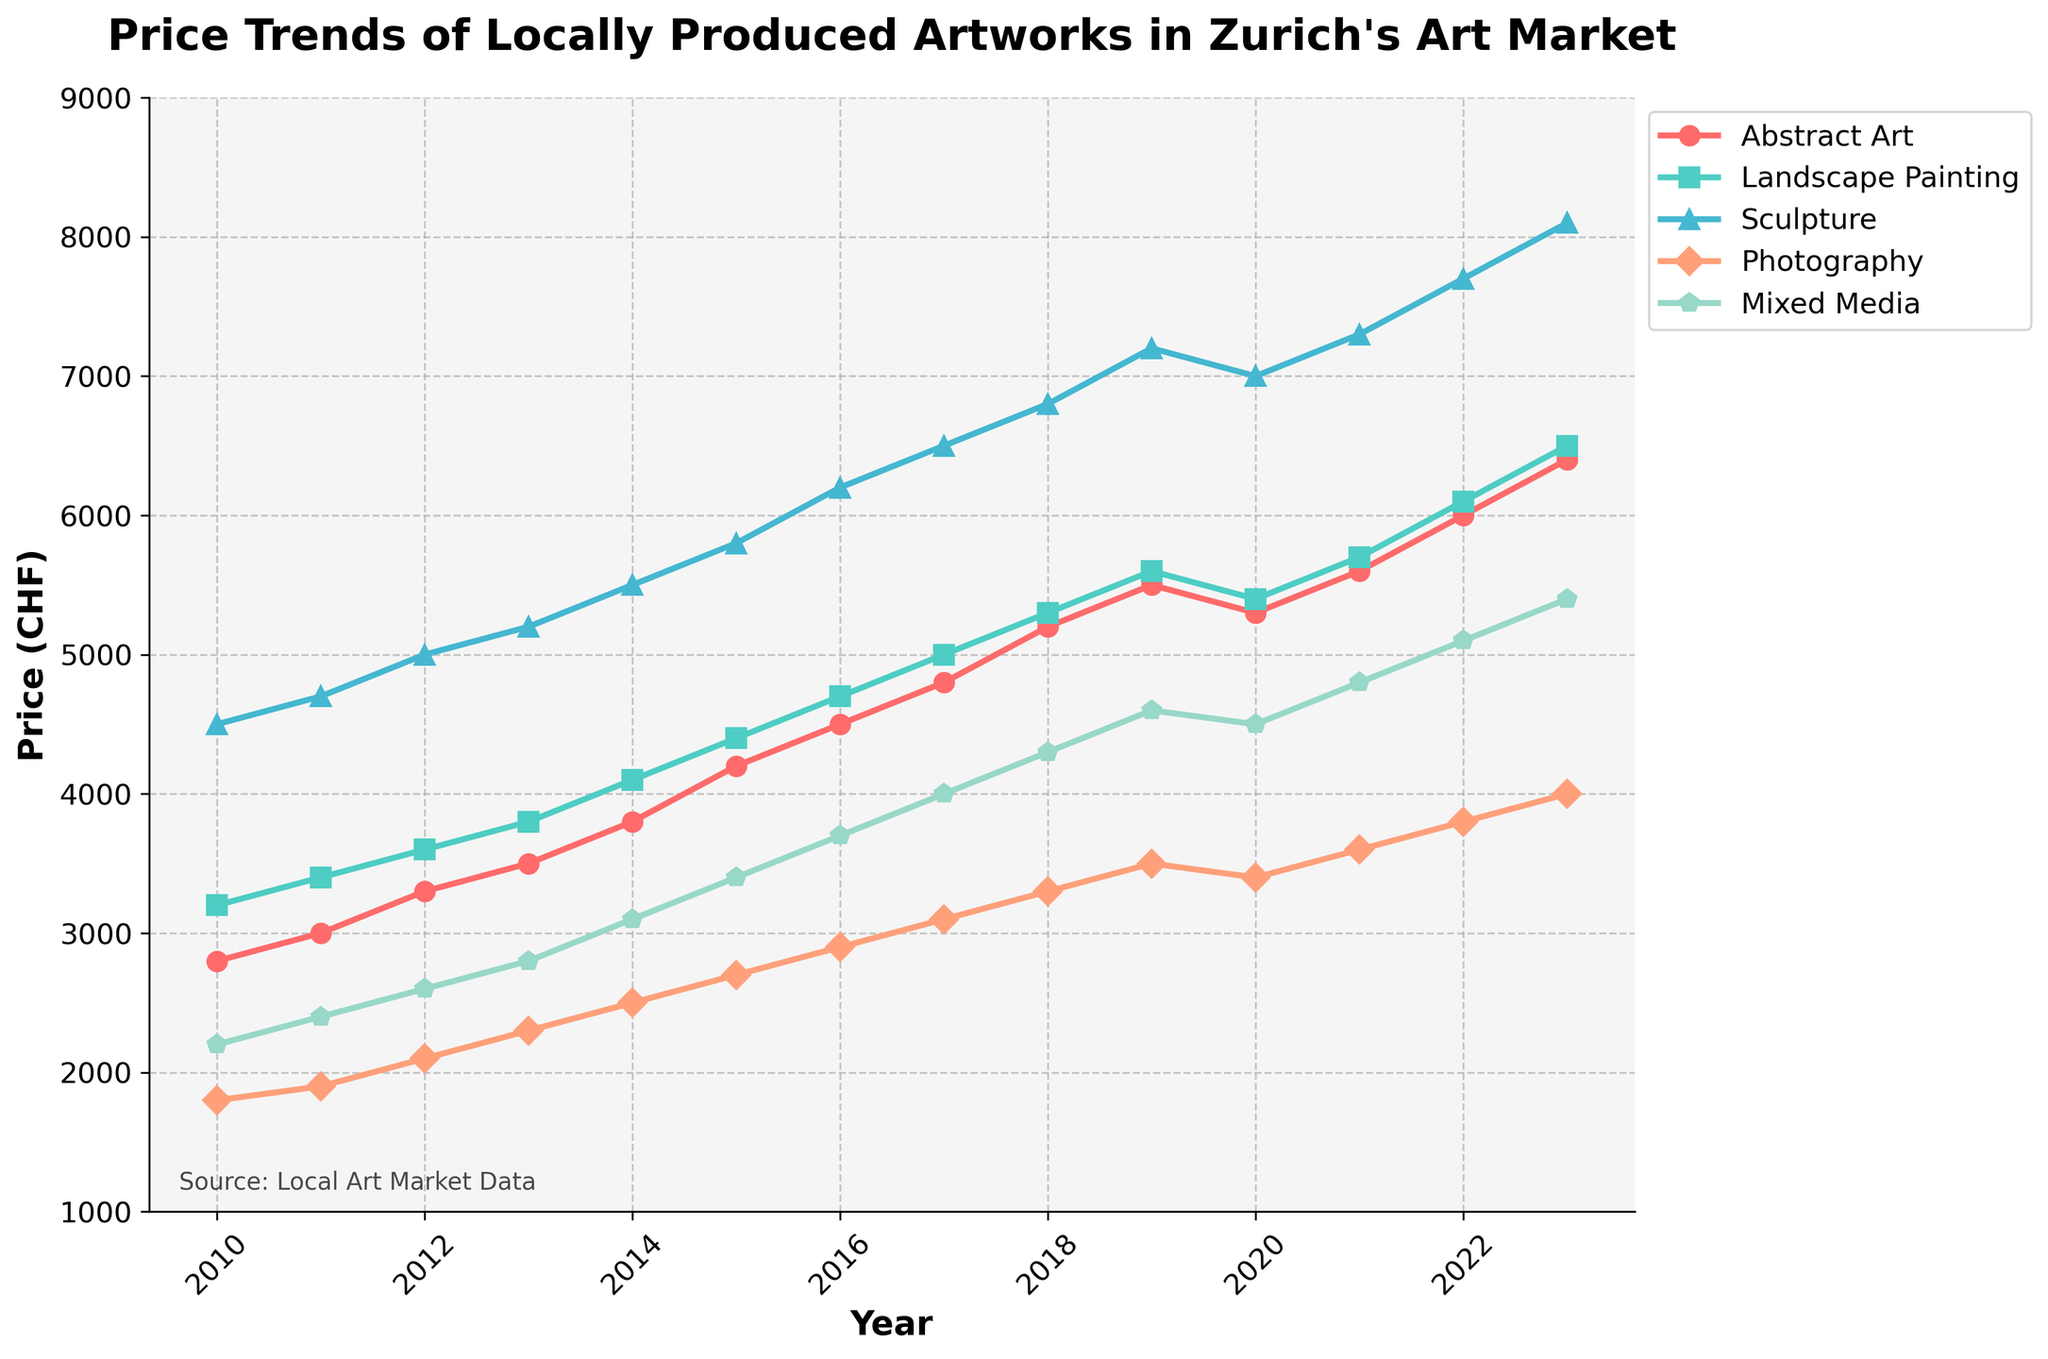How has the price for abstract art evolved from 2010 to 2023? To understand the evolution of the price for abstract art, look at the trend line for "Abstract Art" from 2010 to 2023. Follow its trajectory and note any increases or decreases.
Answer: The price has consistently increased from 2800 CHF in 2010 to 6400 CHF in 2023 In which year did landscape paintings reach a price of 5000 CHF? Inspect the line representing "Landscape Painting" and identify the year where the price value equals 5000 CHF.
Answer: 2017 Which type of artwork had the highest price in 2023? Compare the final data points on the lines for each type of artwork (Abstract Art, Landscape Painting, Sculpture, Photography, Mixed Media) in the year 2023 to determine which one is the highest.
Answer: Sculpture By how much did the price of photography increase from 2010 to 2023? Subtract the photography price in 2010 from the price in 2023 (4000 CHF - 1800 CHF) to find the increase.
Answer: 2200 CHF Was there any type of artwork that experienced a price drop after 2019? Examine the trend lines from 2019 onwards and check for any downward slopes.
Answer: Abstract Art and Landscape Painting What is the average price of mixed media artworks over the period 2010 to 2023? Add up all the price points for Mixed Media from 2010 to 2023, then divide by the number of years (14). (2200+2400+2600+2800+3100+3400+3700+4000+4300+4600+4500+4800+5100+5400)/14
Answer: 3693 CHF Did the price of sculptures ever fall below 5000 CHF after 2012? Check the trend line for "Sculpture" after 2012 and see if it ever dips below 5000 CHF.
Answer: No By what percentage did the price of landscape painting change from 2010 to 2013? Calculate the percentage change between 2010 (3200 CHF) and 2013 (3800 CHF). ((3800 - 3200) / 3200) * 100 = 18.75%
Answer: 18.75% Which artwork had a steeper price increase between 2010 and 2023: Abstract Art or Mixed Media? Calculate the difference between 2023 and 2010 prices for both artworks and compare (Abstract Art: 6400-2800, Mixed Media: 5400-2200).
Answer: Mixed Media (3200 CHF) In what year did the price of sculptures reach 6500 CHF? Identify the year where the "Sculpture" trend line intersects with the 6500 CHF price point.
Answer: 2017 